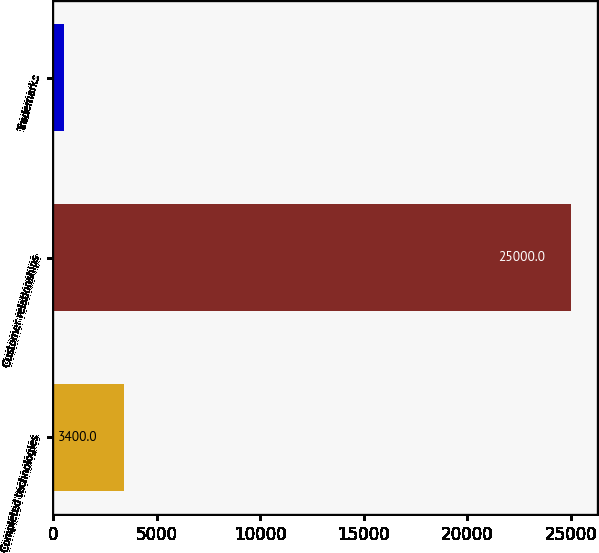<chart> <loc_0><loc_0><loc_500><loc_500><bar_chart><fcel>Completed technologies<fcel>Customer relationships<fcel>Trademarks<nl><fcel>3400<fcel>25000<fcel>500<nl></chart> 